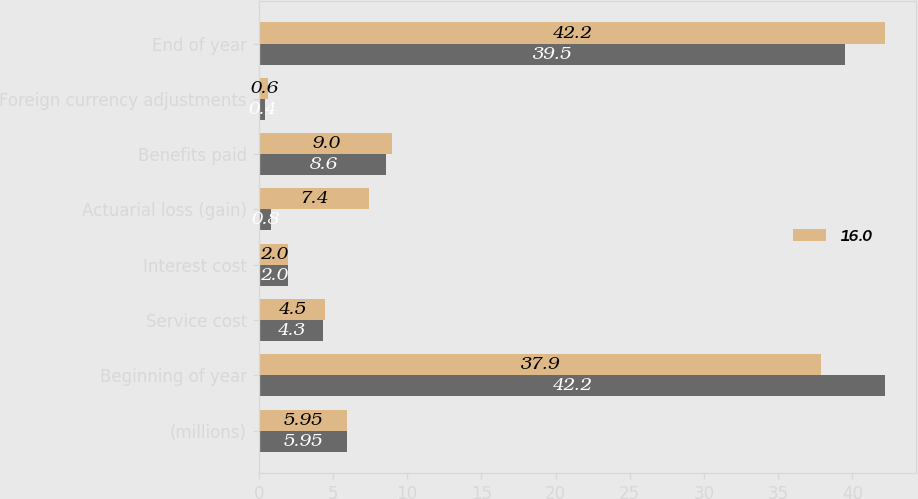Convert chart. <chart><loc_0><loc_0><loc_500><loc_500><stacked_bar_chart><ecel><fcel>(millions)<fcel>Beginning of year<fcel>Service cost<fcel>Interest cost<fcel>Actuarial loss (gain)<fcel>Benefits paid<fcel>Foreign currency adjustments<fcel>End of year<nl><fcel>nan<fcel>5.95<fcel>42.2<fcel>4.3<fcel>2<fcel>0.8<fcel>8.6<fcel>0.4<fcel>39.5<nl><fcel>16<fcel>5.95<fcel>37.9<fcel>4.5<fcel>2<fcel>7.4<fcel>9<fcel>0.6<fcel>42.2<nl></chart> 